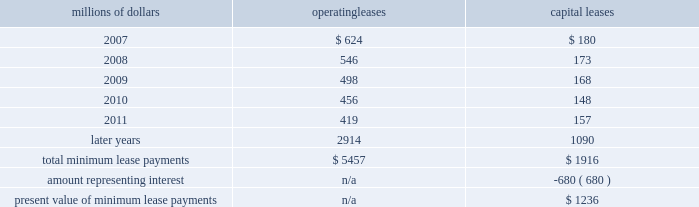Depending upon our senior unsecured debt ratings .
The facilities require the maintenance of a minimum net worth and a debt to net worth coverage ratio .
At december 31 , 2006 , we were in compliance with these covenants .
The facilities do not include any other financial restrictions , credit rating triggers ( other than rating-dependent pricing ) , or any other provision that could require the posting of collateral .
In addition to our revolving credit facilities , we had $ 150 million in uncommitted lines of credit available , including $ 75 million that expires in march 2007 and $ 75 million expiring in may 2007 .
Neither of these lines of credit were used as of december 31 , 2006 .
We must have equivalent credit available under our five-year facilities to draw on these $ 75 million lines .
Dividend restrictions 2013 we are subject to certain restrictions related to the payment of cash dividends to our shareholders due to minimum net worth requirements under the credit facilities referred to above .
The amount of retained earnings available for dividends was $ 7.8 billion and $ 6.2 billion at december 31 , 2006 and 2005 , respectively .
We do not expect that these restrictions will have a material adverse effect on our consolidated financial condition , results of operations , or liquidity .
We declared dividends of $ 323 million in 2006 and $ 316 million in 2005 .
Shelf registration statement 2013 under a current shelf registration statement , we may issue any combination of debt securities , preferred stock , common stock , or warrants for debt securities or preferred stock in one or more offerings .
At december 31 , 2006 , we had $ 500 million remaining for issuance under the current shelf registration statement .
We have no immediate plans to issue any securities ; however , we routinely consider and evaluate opportunities to replace existing debt or access capital through issuances of debt securities under this shelf registration , and , therefore , we may issue debt securities at any time .
Leases we lease certain locomotives , freight cars , and other property .
Future minimum lease payments for operating and capital leases with initial or remaining non-cancelable lease terms in excess of one year as of december 31 , 2006 were as follows : millions of dollars operating leases capital leases .
Rent expense for operating leases with terms exceeding one month was $ 798 million in 2006 , $ 728 million in 2005 , and $ 651 million in 2004 .
When cash rental payments are not made on a straight-line basis , we recognize variable rental expense on a straight-line basis over the lease term .
Contingent rentals and sub-rentals are not significant. .
What percentage of total minimum lease payments are operating leases as of december 31 , 2006? 
Computations: (5457 / (5457 + 1916))
Answer: 0.74013. 